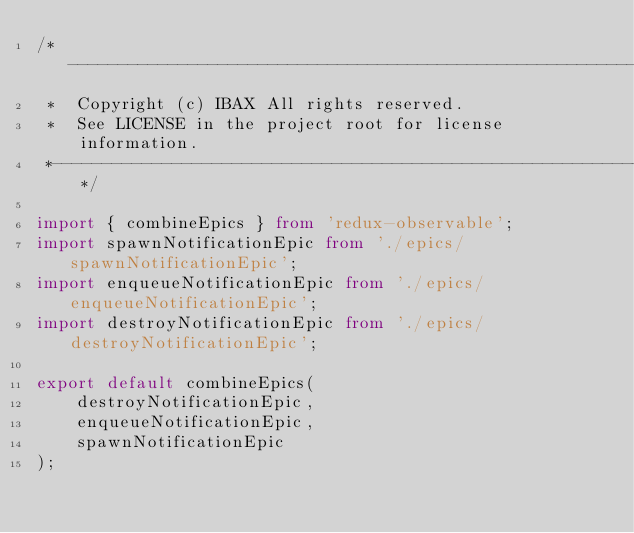Convert code to text. <code><loc_0><loc_0><loc_500><loc_500><_TypeScript_>/*---------------------------------------------------------------------------------------------
 *  Copyright (c) IBAX All rights reserved.
 *  See LICENSE in the project root for license information.
 *--------------------------------------------------------------------------------------------*/

import { combineEpics } from 'redux-observable';
import spawnNotificationEpic from './epics/spawnNotificationEpic';
import enqueueNotificationEpic from './epics/enqueueNotificationEpic';
import destroyNotificationEpic from './epics/destroyNotificationEpic';

export default combineEpics(
    destroyNotificationEpic,
    enqueueNotificationEpic,
    spawnNotificationEpic
);</code> 